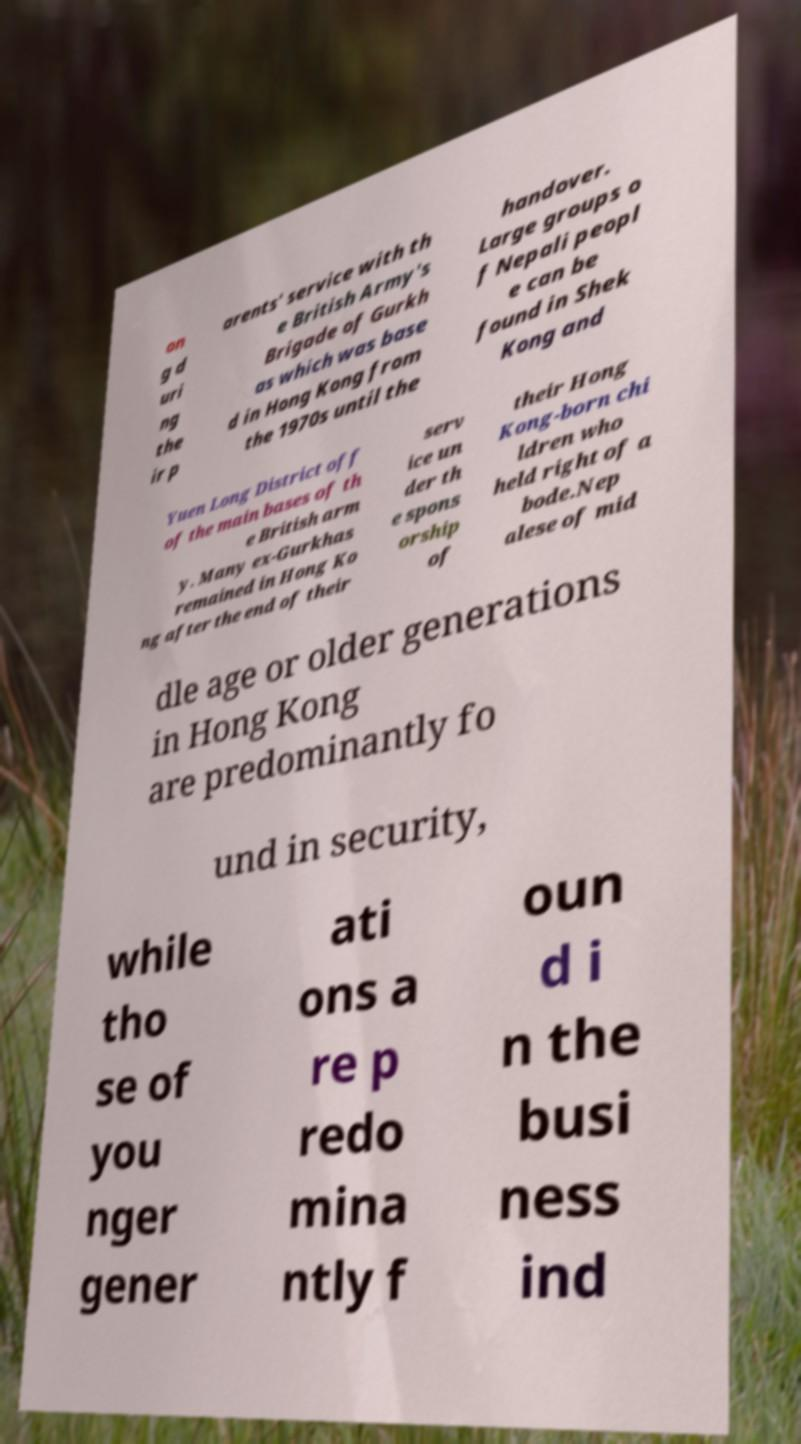There's text embedded in this image that I need extracted. Can you transcribe it verbatim? on g d uri ng the ir p arents' service with th e British Army's Brigade of Gurkh as which was base d in Hong Kong from the 1970s until the handover. Large groups o f Nepali peopl e can be found in Shek Kong and Yuen Long District off of the main bases of th e British arm y. Many ex-Gurkhas remained in Hong Ko ng after the end of their serv ice un der th e spons orship of their Hong Kong-born chi ldren who held right of a bode.Nep alese of mid dle age or older generations in Hong Kong are predominantly fo und in security, while tho se of you nger gener ati ons a re p redo mina ntly f oun d i n the busi ness ind 